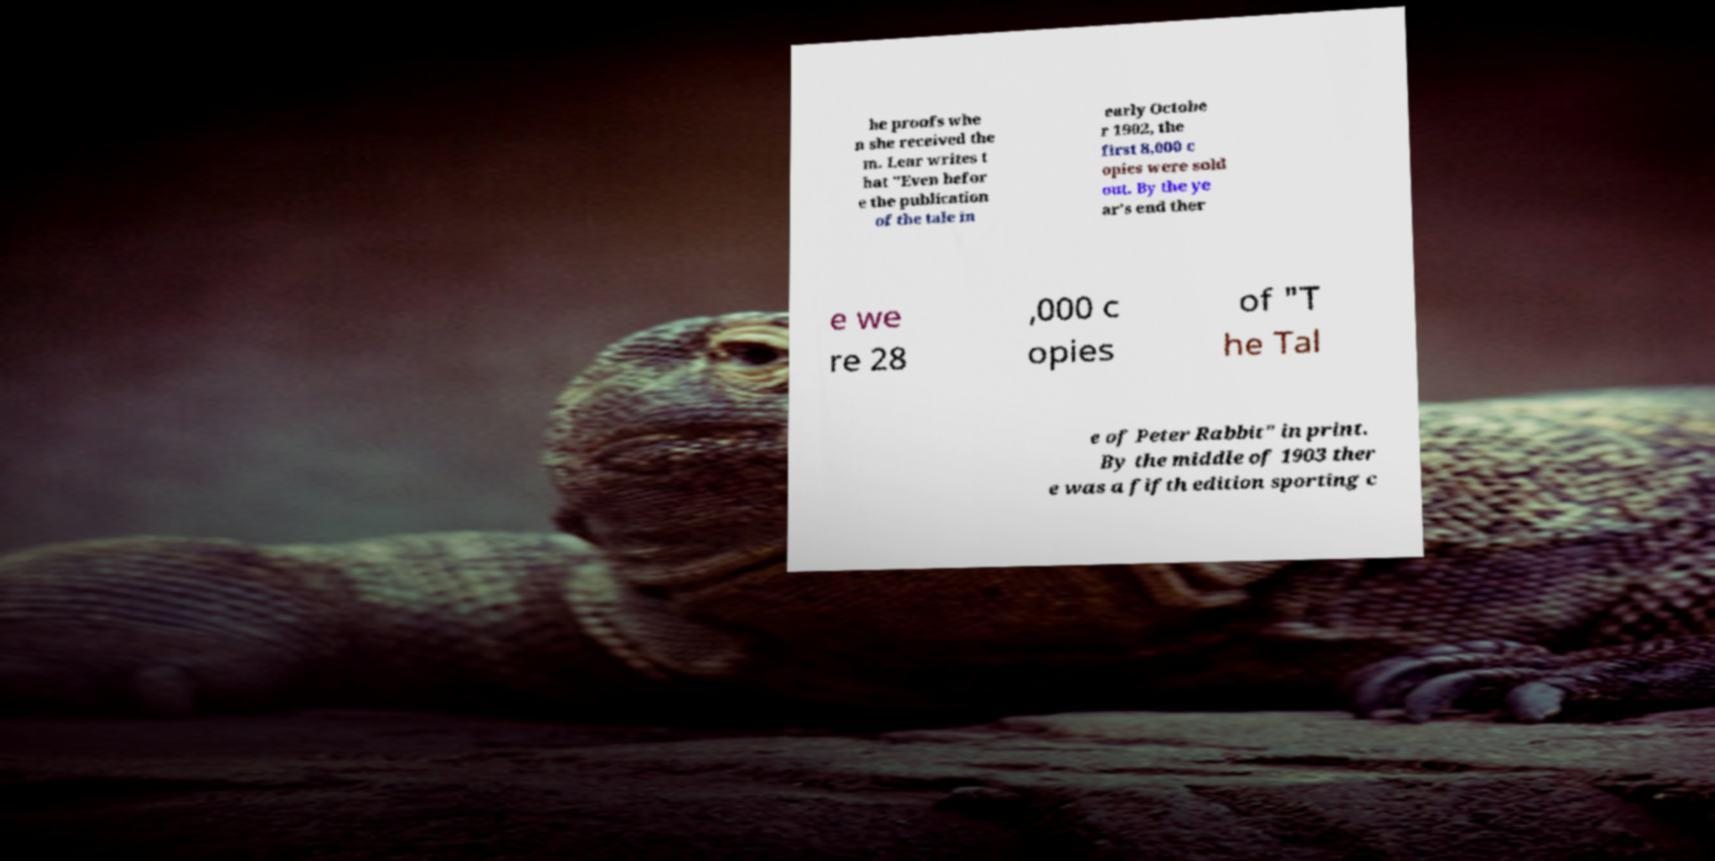There's text embedded in this image that I need extracted. Can you transcribe it verbatim? he proofs whe n she received the m. Lear writes t hat "Even befor e the publication of the tale in early Octobe r 1902, the first 8,000 c opies were sold out. By the ye ar's end ther e we re 28 ,000 c opies of "T he Tal e of Peter Rabbit" in print. By the middle of 1903 ther e was a fifth edition sporting c 